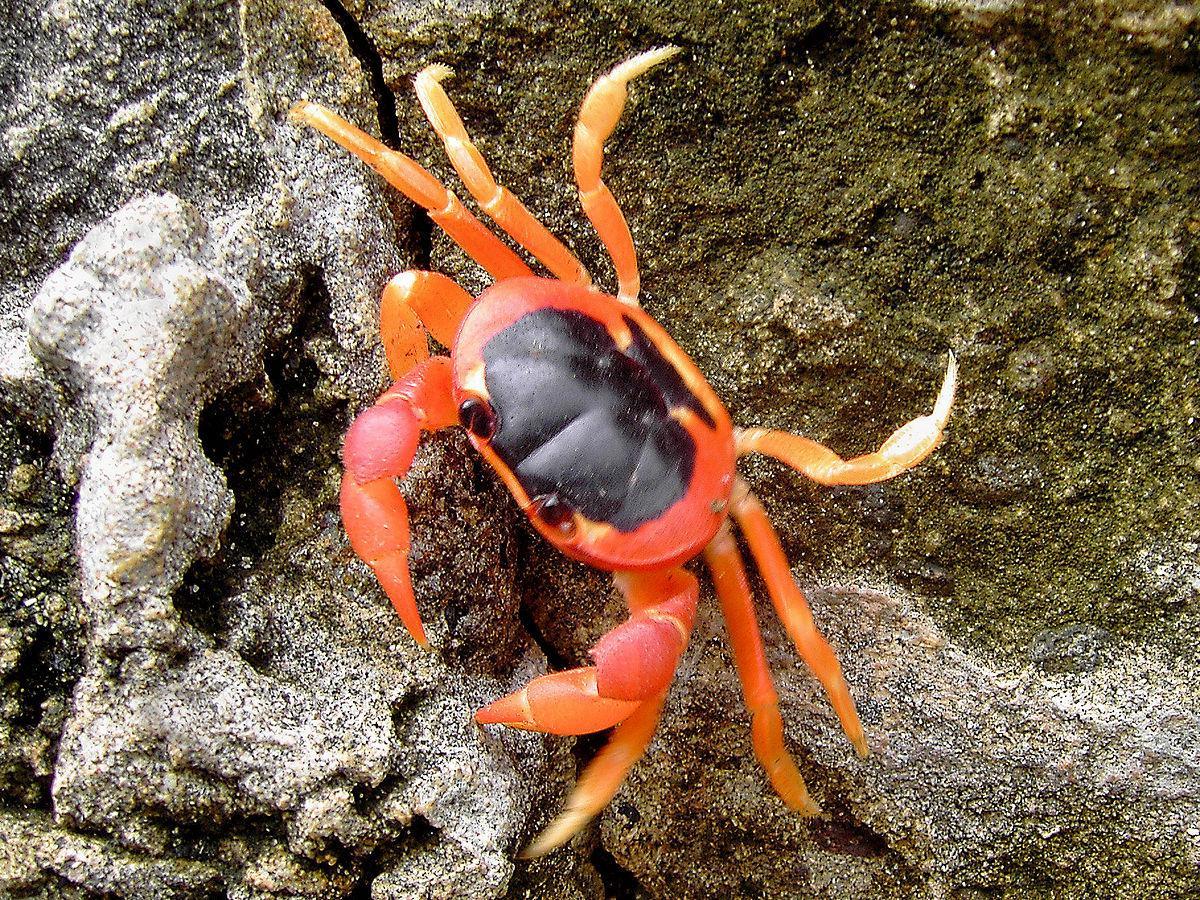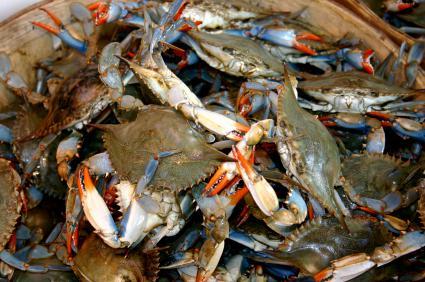The first image is the image on the left, the second image is the image on the right. Analyze the images presented: Is the assertion "There are more than three crabs." valid? Answer yes or no. Yes. The first image is the image on the left, the second image is the image on the right. Assess this claim about the two images: "One image shows the top of a reddish-orange crab, and the other image shows the bottom of at least one crab.". Correct or not? Answer yes or no. No. 